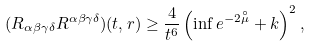Convert formula to latex. <formula><loc_0><loc_0><loc_500><loc_500>( R _ { \alpha \beta \gamma \delta } R ^ { \alpha \beta \gamma \delta } ) ( t , r ) \geq \frac { 4 } { t ^ { 6 } } \left ( \inf e ^ { - 2 \overset { \circ } { \mu } } + k \right ) ^ { 2 } ,</formula> 